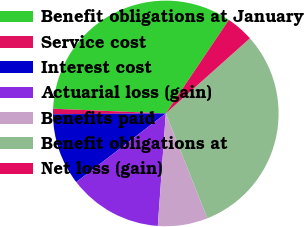Convert chart to OTSL. <chart><loc_0><loc_0><loc_500><loc_500><pie_chart><fcel>Benefit obligations at January<fcel>Service cost<fcel>Interest cost<fcel>Actuarial loss (gain)<fcel>Benefits paid<fcel>Benefit obligations at<fcel>Net loss (gain)<nl><fcel>33.77%<fcel>0.79%<fcel>10.29%<fcel>13.46%<fcel>7.13%<fcel>30.6%<fcel>3.96%<nl></chart> 